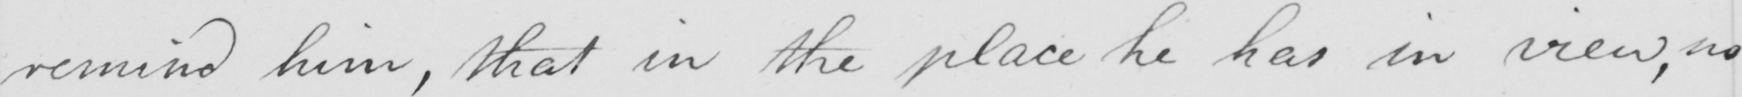What is written in this line of handwriting? remind him, that in the place he has in view, no 